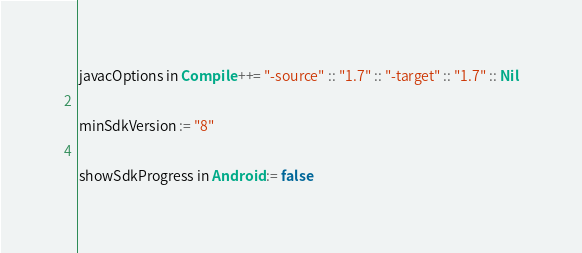Convert code to text. <code><loc_0><loc_0><loc_500><loc_500><_Scala_>javacOptions in Compile ++= "-source" :: "1.7" :: "-target" :: "1.7" :: Nil

minSdkVersion := "8"

showSdkProgress in Android := false
</code> 